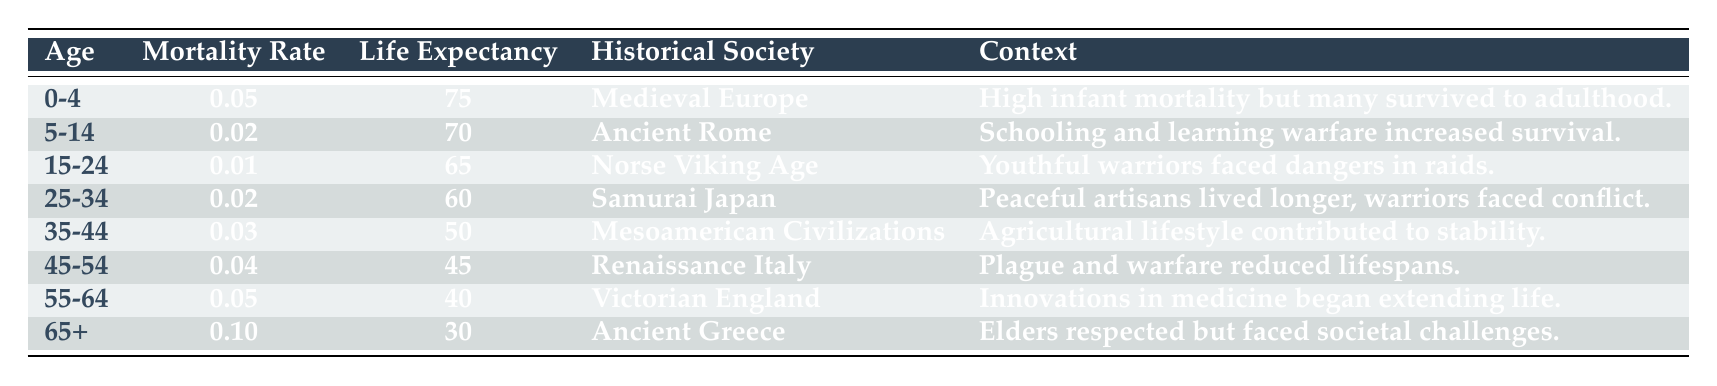What is the mortality rate for the age group 45-54 in Renaissance Italy? The table shows that the mortality rate for the age group 45-54 is 0.04 in Renaissance Italy.
Answer: 0.04 What is the life expectancy for individuals aged 65 and older in Ancient Greece? According to the table, the life expectancy for individuals aged 65 and older in Ancient Greece is 30.
Answer: 30 Which historical society had the highest life expectancy in the age group 0-4? The table indicates that Medieval Europe had the highest life expectancy in the age group 0-4, which is 75.
Answer: Medieval Europe What age group had a mortality rate of 0.01, and which historical society does it belong to? Looking at the table, the age group 15-24 has a mortality rate of 0.01, associated with Norse Viking Age.
Answer: 15-24, Norse Viking Age What is the average life expectancy across the listed historical societies for the age group 25-34? The life expectancies for the age group 25-34 are 60 (Samurai Japan) only, thus the average is simply 60/1 = 60.
Answer: 60 Is the mortality rate for the age group 55-64 in Victorian England higher than that for the group 45-54 in Renaissance Italy? The mortality rate for the age group 55-64 in Victorian England is 0.05, while the rate for 45-54 in Renaissance Italy is 0.04. Since 0.05 > 0.04, the statement is true.
Answer: Yes What percentage of life expectancy does the age group 35-44 in Mesoamerican Civilizations represent compared to the maximum life expectancy in the table? The maximum life expectancy in the table is 75 (Medieval Europe), and the life expectancy for 35-44 in Mesoamerican Civilizations is 50. Therefore, the percentage is (50/75) * 100 = 66.67%.
Answer: 66.67% Was the context of high infant mortality accompanied by many surviving to adulthood specific to any particular society? The table reflects this context specifically for Medieval Europe.
Answer: Yes, Medieval Europe Which historical society experienced air conflicts reducing lifespan for the age group 45-54? By analyzing the table, Renaissance Italy is noted for plague and warfare reducing lifespans in the 45-54 age group.
Answer: Renaissance Italy 